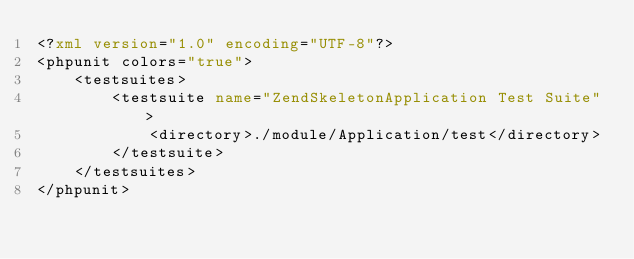<code> <loc_0><loc_0><loc_500><loc_500><_XML_><?xml version="1.0" encoding="UTF-8"?>
<phpunit colors="true">
    <testsuites>
        <testsuite name="ZendSkeletonApplication Test Suite">
            <directory>./module/Application/test</directory>
        </testsuite>
    </testsuites>
</phpunit>
</code> 